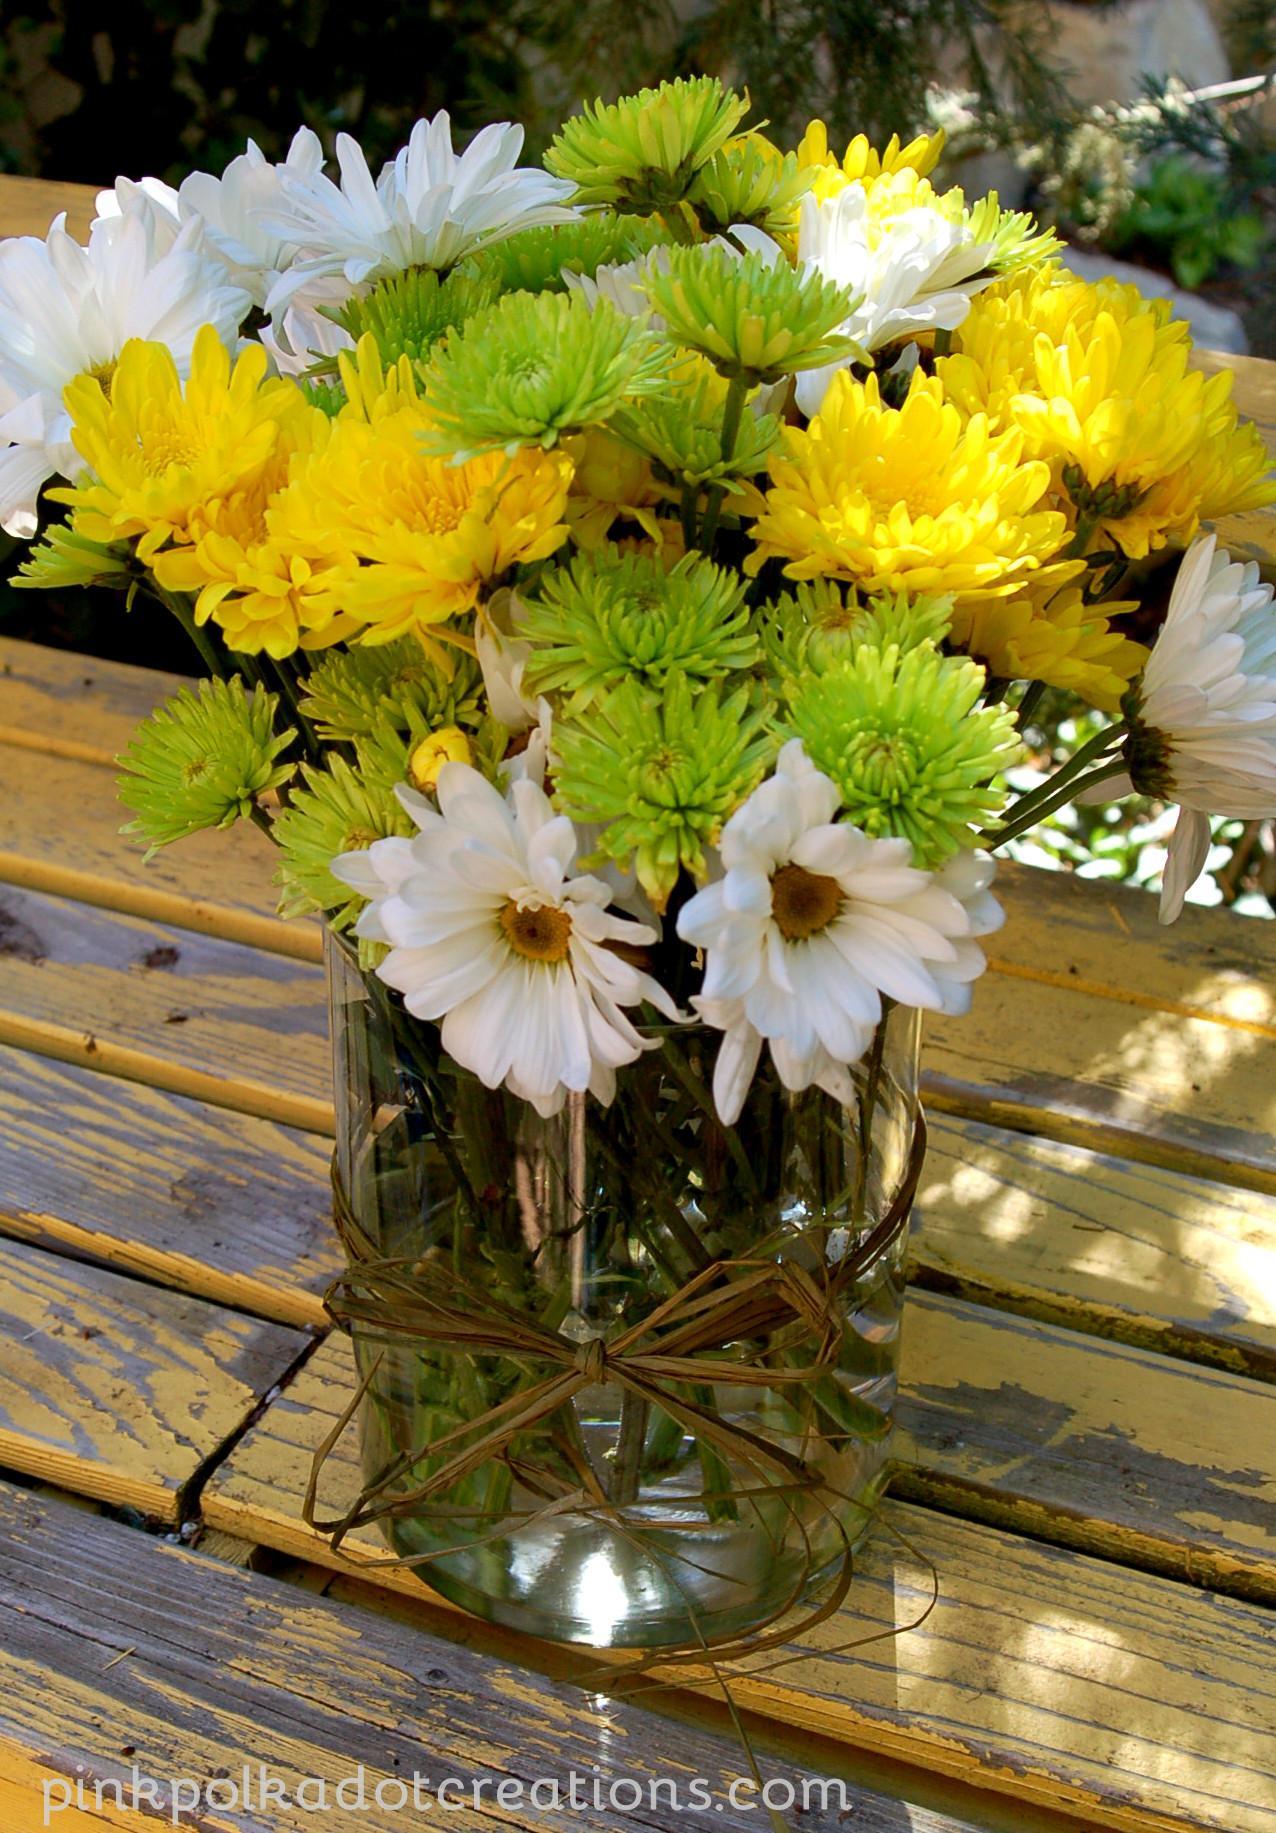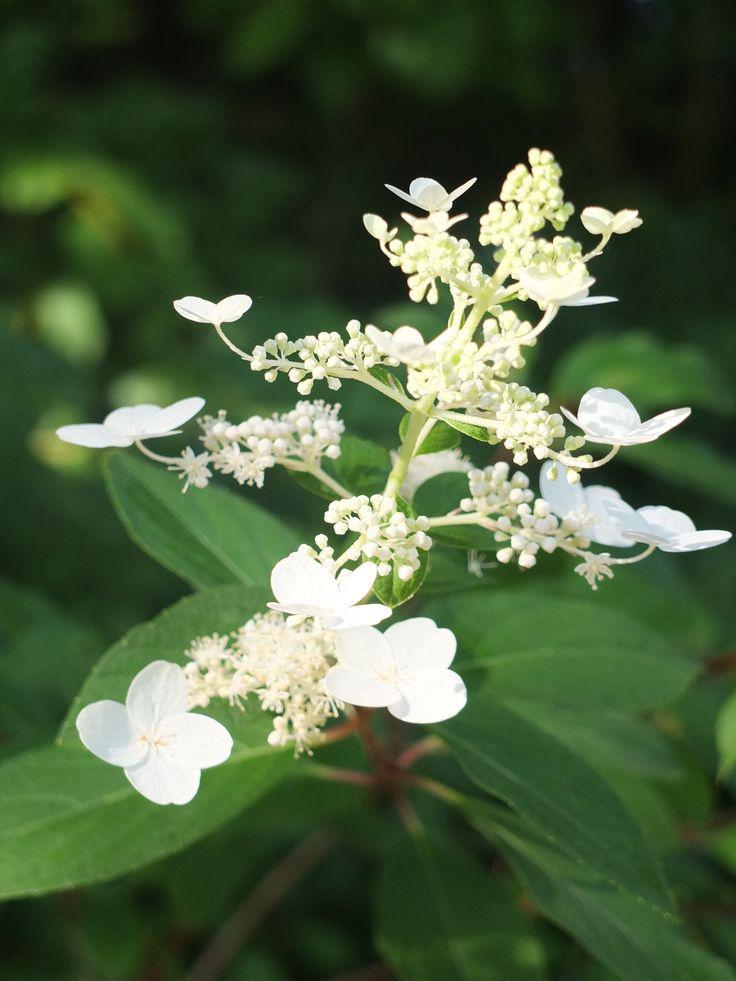The first image is the image on the left, the second image is the image on the right. Examine the images to the left and right. Is the description "At least one vase is hanging." accurate? Answer yes or no. No. 